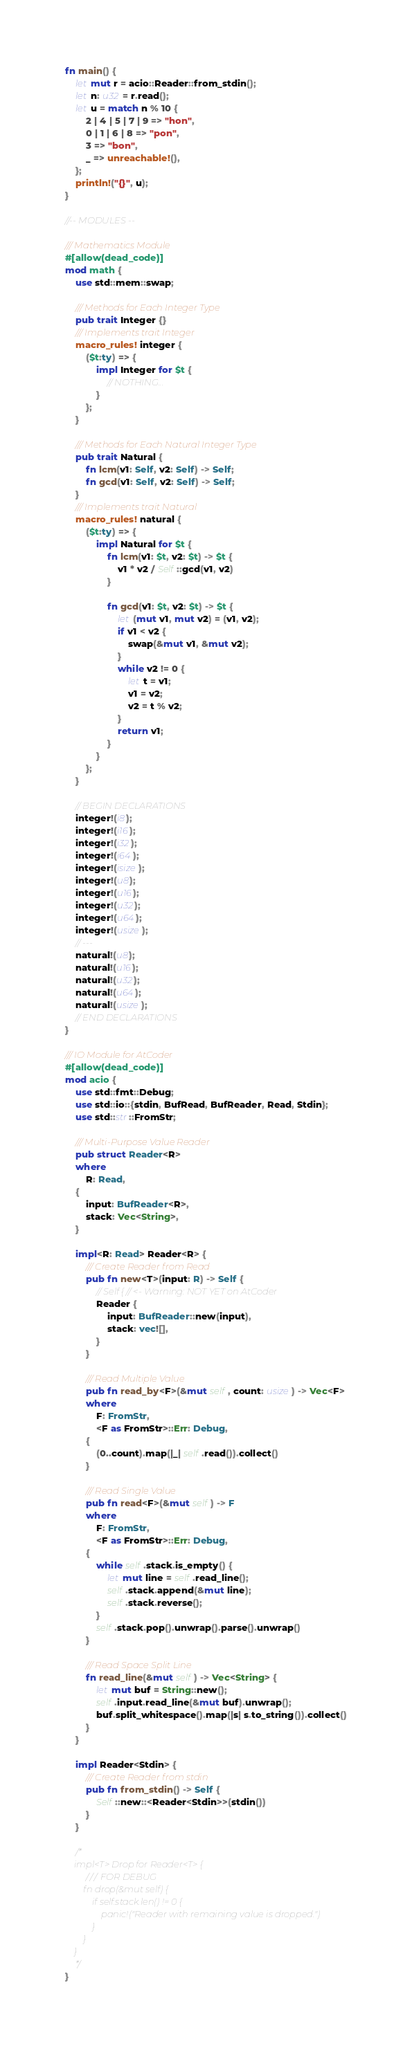<code> <loc_0><loc_0><loc_500><loc_500><_Rust_>fn main() {
    let mut r = acio::Reader::from_stdin();
    let n: u32 = r.read();
    let u = match n % 10 {
        2 | 4 | 5 | 7 | 9 => "hon",
        0 | 1 | 6 | 8 => "pon",
        3 => "bon",
        _ => unreachable!(),
    };
    println!("{}", u);
}

//-- MODULES --

/// Mathematics Module
#[allow(dead_code)]
mod math {
    use std::mem::swap;

    /// Methods for Each Integer Type
    pub trait Integer {}
    /// Implements trait Integer
    macro_rules! integer {
        ($t:ty) => {
            impl Integer for $t {
                // NOTHING...
            }
        };
    }

    /// Methods for Each Natural Integer Type
    pub trait Natural {
        fn lcm(v1: Self, v2: Self) -> Self;
        fn gcd(v1: Self, v2: Self) -> Self;
    }
    /// Implements trait Natural
    macro_rules! natural {
        ($t:ty) => {
            impl Natural for $t {
                fn lcm(v1: $t, v2: $t) -> $t {
                    v1 * v2 / Self::gcd(v1, v2)
                }

                fn gcd(v1: $t, v2: $t) -> $t {
                    let (mut v1, mut v2) = (v1, v2);
                    if v1 < v2 {
                        swap(&mut v1, &mut v2);
                    }
                    while v2 != 0 {
                        let t = v1;
                        v1 = v2;
                        v2 = t % v2;
                    }
                    return v1;
                }
            }
        };
    }

    // BEGIN DECLARATIONS
    integer!(i8);
    integer!(i16);
    integer!(i32);
    integer!(i64);
    integer!(isize);
    integer!(u8);
    integer!(u16);
    integer!(u32);
    integer!(u64);
    integer!(usize);
    // ---
    natural!(u8);
    natural!(u16);
    natural!(u32);
    natural!(u64);
    natural!(usize);
    // END DECLARATIONS
}

/// IO Module for AtCoder
#[allow(dead_code)]
mod acio {
    use std::fmt::Debug;
    use std::io::{stdin, BufRead, BufReader, Read, Stdin};
    use std::str::FromStr;

    /// Multi-Purpose Value Reader
    pub struct Reader<R>
    where
        R: Read,
    {
        input: BufReader<R>,
        stack: Vec<String>,
    }

    impl<R: Read> Reader<R> {
        /// Create Reader from Read
        pub fn new<T>(input: R) -> Self {
            // Self { // <- Warning: NOT YET on AtCoder
            Reader {
                input: BufReader::new(input),
                stack: vec![],
            }
        }

        /// Read Multiple Value
        pub fn read_by<F>(&mut self, count: usize) -> Vec<F>
        where
            F: FromStr,
            <F as FromStr>::Err: Debug,
        {
            (0..count).map(|_| self.read()).collect()
        }

        /// Read Single Value
        pub fn read<F>(&mut self) -> F
        where
            F: FromStr,
            <F as FromStr>::Err: Debug,
        {
            while self.stack.is_empty() {
                let mut line = self.read_line();
                self.stack.append(&mut line);
                self.stack.reverse();
            }
            self.stack.pop().unwrap().parse().unwrap()
        }

        /// Read Space Split Line
        fn read_line(&mut self) -> Vec<String> {
            let mut buf = String::new();
            self.input.read_line(&mut buf).unwrap();
            buf.split_whitespace().map(|s| s.to_string()).collect()
        }
    }

    impl Reader<Stdin> {
        /// Create Reader from stdin
        pub fn from_stdin() -> Self {
            Self::new::<Reader<Stdin>>(stdin())
        }
    }

    /*
    impl<T> Drop for Reader<T> {
        /// FOR DEBUG
        fn drop(&mut self) {
            if self.stack.len() != 0 {
                panic!("Reader with remaining value is dropped.")
            }
        }
    }
    */
}
</code> 